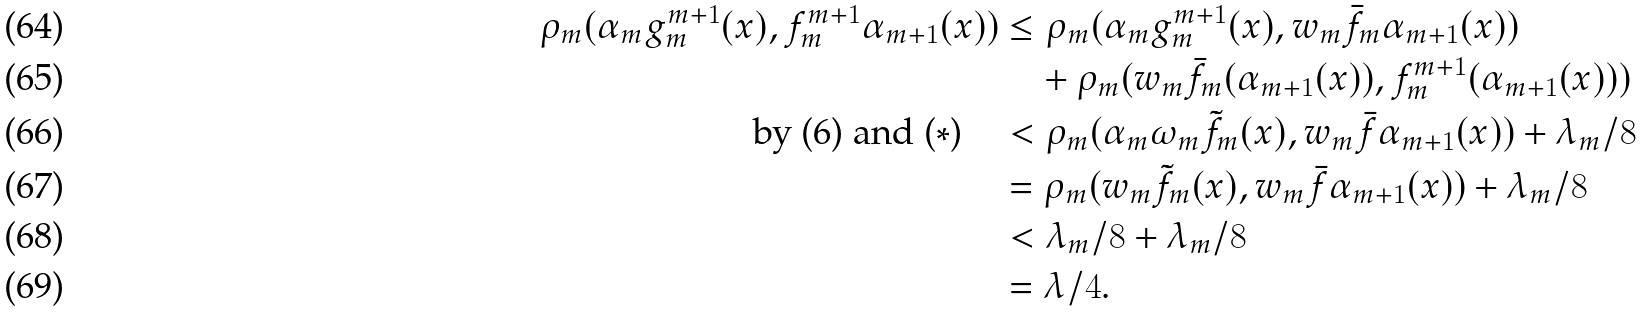<formula> <loc_0><loc_0><loc_500><loc_500>\rho _ { m } ( \alpha _ { m } g ^ { m + 1 } _ { m } ( x ) , f ^ { m + 1 } _ { m } \alpha _ { m + 1 } ( x ) ) & \leq \rho _ { m } ( \alpha _ { m } g ^ { m + 1 } _ { m } ( x ) , w _ { m } \bar { f } _ { m } \alpha _ { m + 1 } ( x ) ) \\ & \quad + \rho _ { m } ( w _ { m } \bar { f } _ { m } ( \alpha _ { m + 1 } ( x ) ) , f ^ { m + 1 } _ { m } ( \alpha _ { m + 1 } ( x ) ) ) \\ \text {by (6) and ($\ast$)\quad} & < \rho _ { m } ( \alpha _ { m } \omega _ { m } \tilde { f } _ { m } ( x ) , w _ { m } \bar { f } \alpha _ { m + 1 } ( x ) ) + \lambda _ { m } / 8 \\ & = \rho _ { m } ( w _ { m } \tilde { f } _ { m } ( x ) , w _ { m } \bar { f } \alpha _ { m + 1 } ( x ) ) + \lambda _ { m } / 8 \\ & < \lambda _ { m } / 8 + \lambda _ { m } / 8 \\ & = \lambda / 4 .</formula> 